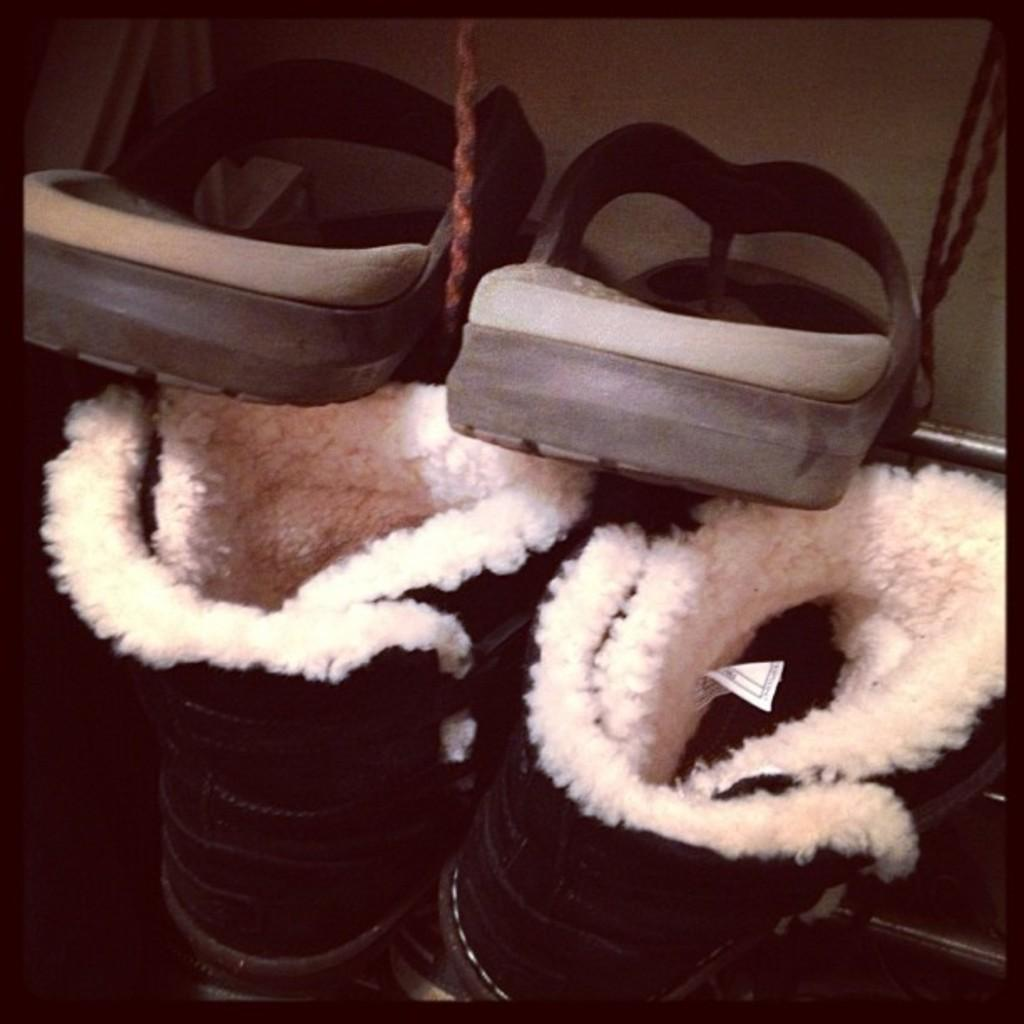How many pairs of footwear are visible in the image? There are 2 pairs of footwear in the image. What else can be seen in the image besides the footwear? There are ropes in the image. What activity is the finger performing in the image? There is no finger present in the image, so it is not possible to answer that question. 